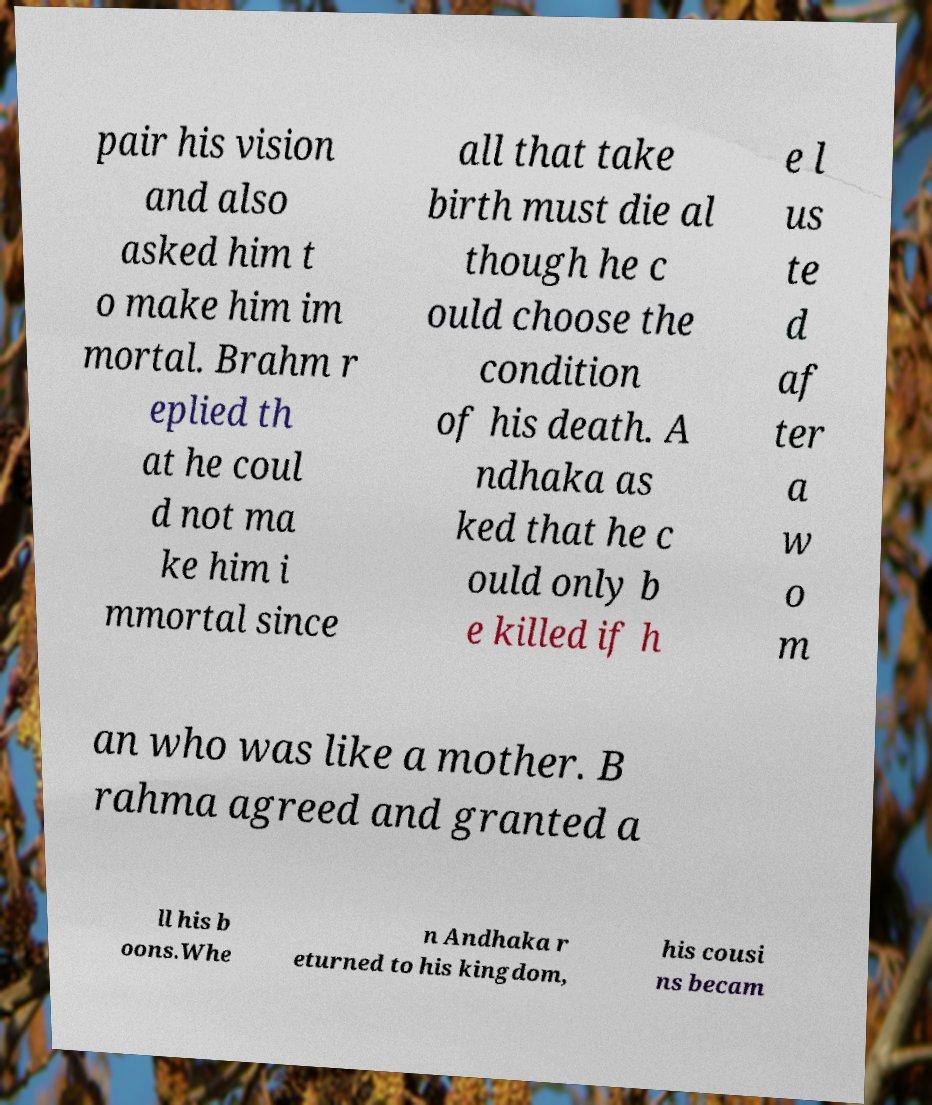For documentation purposes, I need the text within this image transcribed. Could you provide that? pair his vision and also asked him t o make him im mortal. Brahm r eplied th at he coul d not ma ke him i mmortal since all that take birth must die al though he c ould choose the condition of his death. A ndhaka as ked that he c ould only b e killed if h e l us te d af ter a w o m an who was like a mother. B rahma agreed and granted a ll his b oons.Whe n Andhaka r eturned to his kingdom, his cousi ns becam 